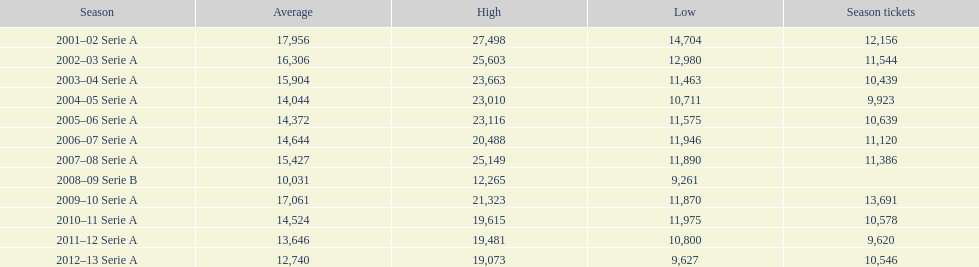What was the mean value in 2001? 17,956. Parse the table in full. {'header': ['Season', 'Average', 'High', 'Low', 'Season tickets'], 'rows': [['2001–02 Serie A', '17,956', '27,498', '14,704', '12,156'], ['2002–03 Serie A', '16,306', '25,603', '12,980', '11,544'], ['2003–04 Serie A', '15,904', '23,663', '11,463', '10,439'], ['2004–05 Serie A', '14,044', '23,010', '10,711', '9,923'], ['2005–06 Serie A', '14,372', '23,116', '11,575', '10,639'], ['2006–07 Serie A', '14,644', '20,488', '11,946', '11,120'], ['2007–08 Serie A', '15,427', '25,149', '11,890', '11,386'], ['2008–09 Serie B', '10,031', '12,265', '9,261', ''], ['2009–10 Serie A', '17,061', '21,323', '11,870', '13,691'], ['2010–11 Serie A', '14,524', '19,615', '11,975', '10,578'], ['2011–12 Serie A', '13,646', '19,481', '10,800', '9,620'], ['2012–13 Serie A', '12,740', '19,073', '9,627', '10,546']]} 